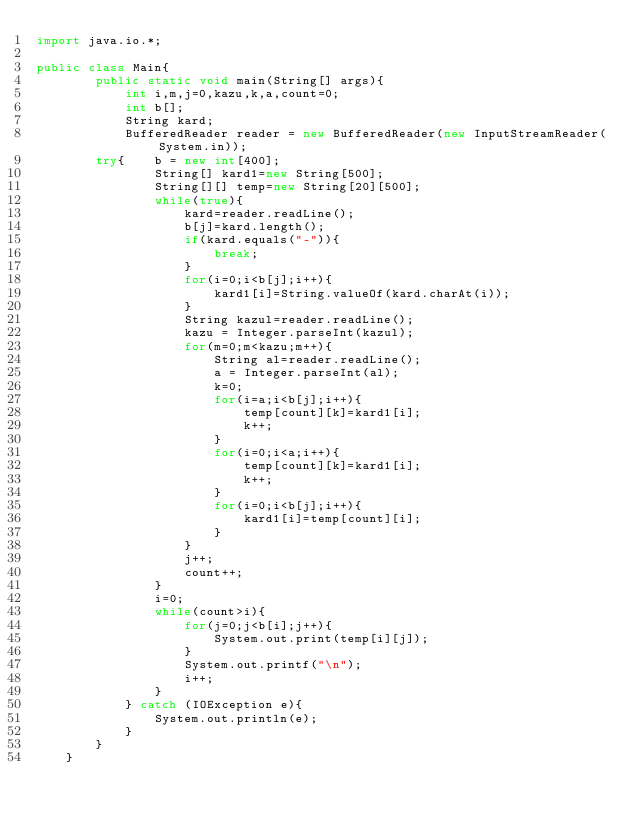Convert code to text. <code><loc_0><loc_0><loc_500><loc_500><_Java_>import java.io.*;

public class Main{ 
        public static void main(String[] args){
            int i,m,j=0,kazu,k,a,count=0;
            int b[];
            String kard;
            BufferedReader reader = new BufferedReader(new InputStreamReader(System.in));
        try{    b = new int[400];
                String[] kard1=new String[500];
                String[][] temp=new String[20][500];
                while(true){
                    kard=reader.readLine();
                    b[j]=kard.length();
                    if(kard.equals("-")){
                        break;
                    }
                    for(i=0;i<b[j];i++){
                        kard1[i]=String.valueOf(kard.charAt(i));
                    }
                    String kazul=reader.readLine();
                    kazu = Integer.parseInt(kazul);
                    for(m=0;m<kazu;m++){
                        String al=reader.readLine();
                        a = Integer.parseInt(al);
                        k=0;
                        for(i=a;i<b[j];i++){
                            temp[count][k]=kard1[i];
                            k++;
                        }
                        for(i=0;i<a;i++){
                            temp[count][k]=kard1[i];
                            k++;
                        }
                        for(i=0;i<b[j];i++){
                            kard1[i]=temp[count][i];
                        }
                    }
                    j++;
                    count++;
                }
                i=0;
                while(count>i){
                    for(j=0;j<b[i];j++){
                        System.out.print(temp[i][j]);
                    }
                    System.out.printf("\n");
                    i++;
                }
            } catch (IOException e){
                System.out.println(e);
            }
        }
    }
</code> 